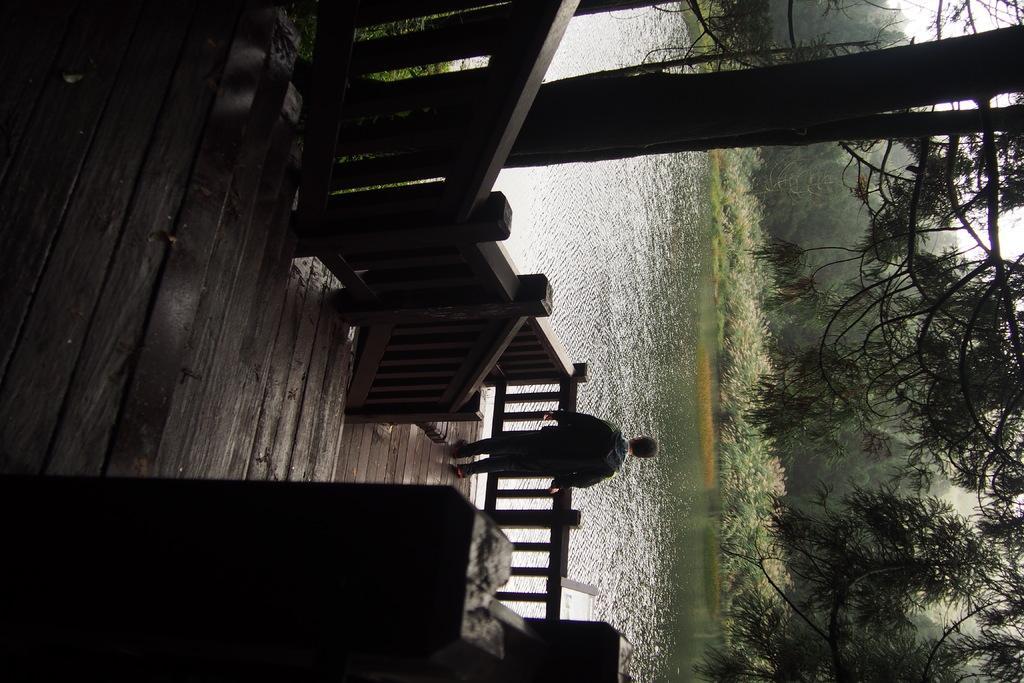Could you give a brief overview of what you see in this image? In this image I can see there is a person standing on the wooden surface beside the fence, in-front of him there are so many trees and water. 